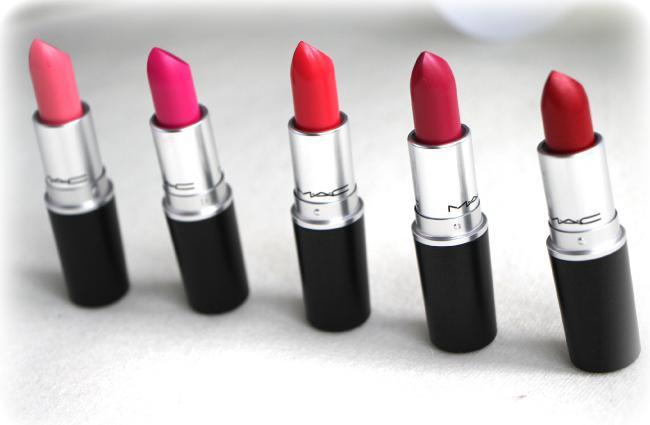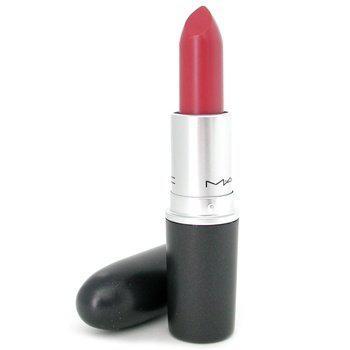The first image is the image on the left, the second image is the image on the right. For the images displayed, is the sentence "Lip shapes are depicted in one or more images." factually correct? Answer yes or no. No. 